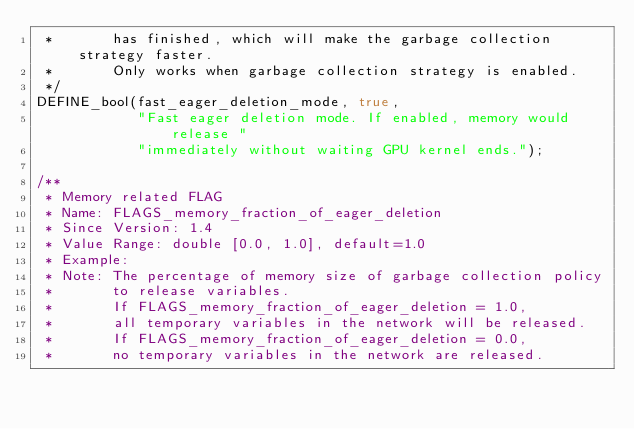Convert code to text. <code><loc_0><loc_0><loc_500><loc_500><_C++_> *       has finished, which will make the garbage collection strategy faster.
 *       Only works when garbage collection strategy is enabled.
 */
DEFINE_bool(fast_eager_deletion_mode, true,
            "Fast eager deletion mode. If enabled, memory would release "
            "immediately without waiting GPU kernel ends.");

/**
 * Memory related FLAG
 * Name: FLAGS_memory_fraction_of_eager_deletion
 * Since Version: 1.4
 * Value Range: double [0.0, 1.0], default=1.0
 * Example:
 * Note: The percentage of memory size of garbage collection policy
 *       to release variables.
 *       If FLAGS_memory_fraction_of_eager_deletion = 1.0,
 *       all temporary variables in the network will be released.
 *       If FLAGS_memory_fraction_of_eager_deletion = 0.0,
 *       no temporary variables in the network are released.</code> 